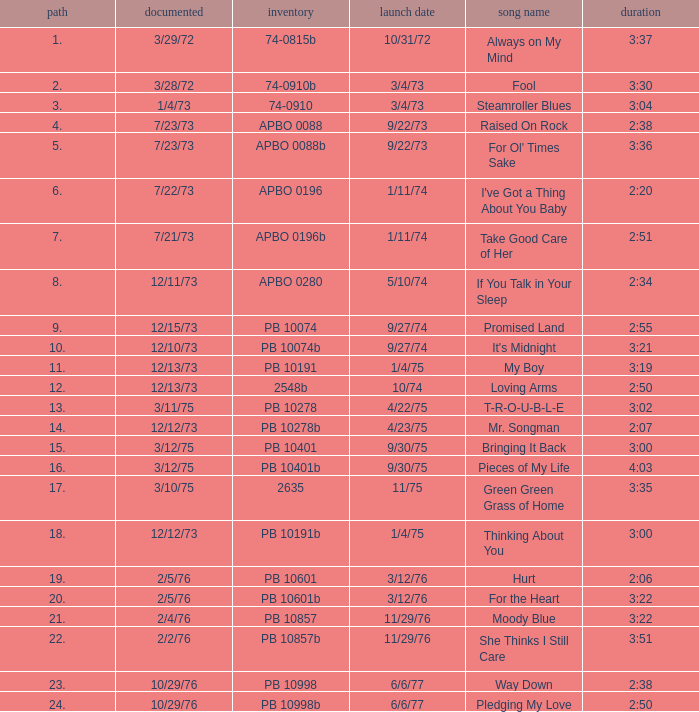Name the catalogue that has tracks less than 13 and the release date of 10/31/72 74-0815b. Could you parse the entire table? {'header': ['path', 'documented', 'inventory', 'launch date', 'song name', 'duration'], 'rows': [['1.', '3/29/72', '74-0815b', '10/31/72', 'Always on My Mind', '3:37'], ['2.', '3/28/72', '74-0910b', '3/4/73', 'Fool', '3:30'], ['3.', '1/4/73', '74-0910', '3/4/73', 'Steamroller Blues', '3:04'], ['4.', '7/23/73', 'APBO 0088', '9/22/73', 'Raised On Rock', '2:38'], ['5.', '7/23/73', 'APBO 0088b', '9/22/73', "For Ol' Times Sake", '3:36'], ['6.', '7/22/73', 'APBO 0196', '1/11/74', "I've Got a Thing About You Baby", '2:20'], ['7.', '7/21/73', 'APBO 0196b', '1/11/74', 'Take Good Care of Her', '2:51'], ['8.', '12/11/73', 'APBO 0280', '5/10/74', 'If You Talk in Your Sleep', '2:34'], ['9.', '12/15/73', 'PB 10074', '9/27/74', 'Promised Land', '2:55'], ['10.', '12/10/73', 'PB 10074b', '9/27/74', "It's Midnight", '3:21'], ['11.', '12/13/73', 'PB 10191', '1/4/75', 'My Boy', '3:19'], ['12.', '12/13/73', '2548b', '10/74', 'Loving Arms', '2:50'], ['13.', '3/11/75', 'PB 10278', '4/22/75', 'T-R-O-U-B-L-E', '3:02'], ['14.', '12/12/73', 'PB 10278b', '4/23/75', 'Mr. Songman', '2:07'], ['15.', '3/12/75', 'PB 10401', '9/30/75', 'Bringing It Back', '3:00'], ['16.', '3/12/75', 'PB 10401b', '9/30/75', 'Pieces of My Life', '4:03'], ['17.', '3/10/75', '2635', '11/75', 'Green Green Grass of Home', '3:35'], ['18.', '12/12/73', 'PB 10191b', '1/4/75', 'Thinking About You', '3:00'], ['19.', '2/5/76', 'PB 10601', '3/12/76', 'Hurt', '2:06'], ['20.', '2/5/76', 'PB 10601b', '3/12/76', 'For the Heart', '3:22'], ['21.', '2/4/76', 'PB 10857', '11/29/76', 'Moody Blue', '3:22'], ['22.', '2/2/76', 'PB 10857b', '11/29/76', 'She Thinks I Still Care', '3:51'], ['23.', '10/29/76', 'PB 10998', '6/6/77', 'Way Down', '2:38'], ['24.', '10/29/76', 'PB 10998b', '6/6/77', 'Pledging My Love', '2:50']]} 